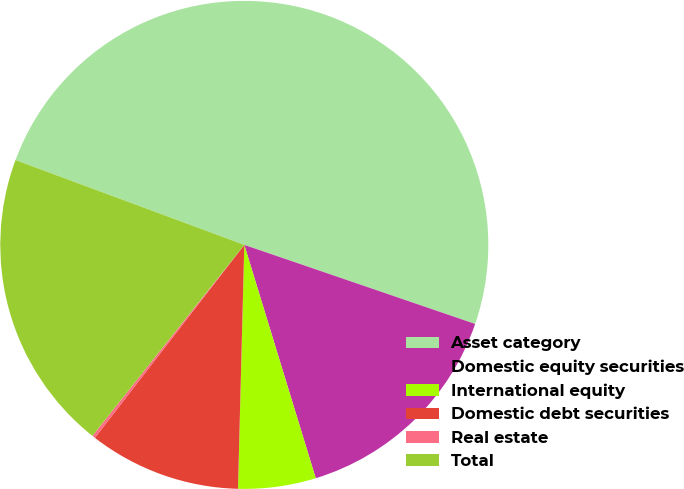Convert chart. <chart><loc_0><loc_0><loc_500><loc_500><pie_chart><fcel>Asset category<fcel>Domestic equity securities<fcel>International equity<fcel>Domestic debt securities<fcel>Real estate<fcel>Total<nl><fcel>49.6%<fcel>15.02%<fcel>5.14%<fcel>10.08%<fcel>0.2%<fcel>19.96%<nl></chart> 